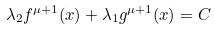Convert formula to latex. <formula><loc_0><loc_0><loc_500><loc_500>\lambda _ { 2 } f ^ { \mu + 1 } ( x ) + \lambda _ { 1 } g ^ { \mu + 1 } ( x ) = C</formula> 